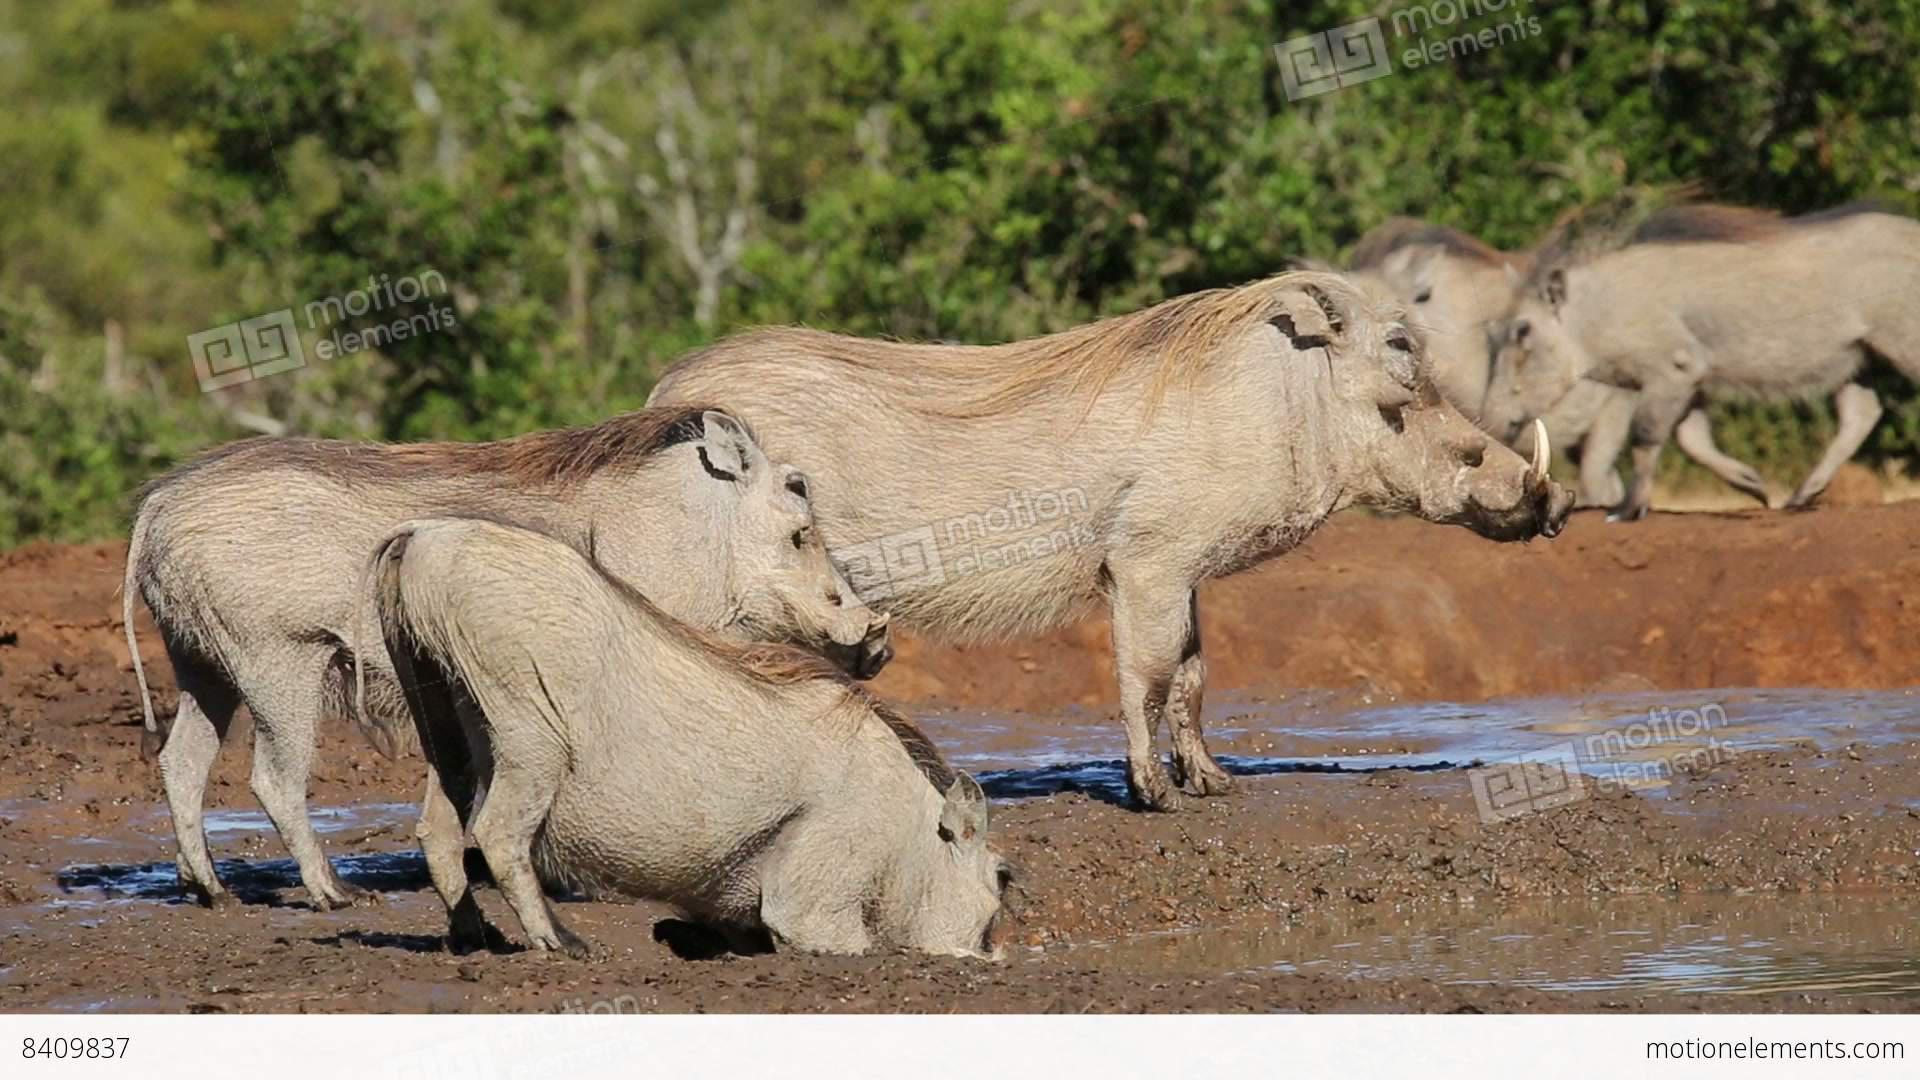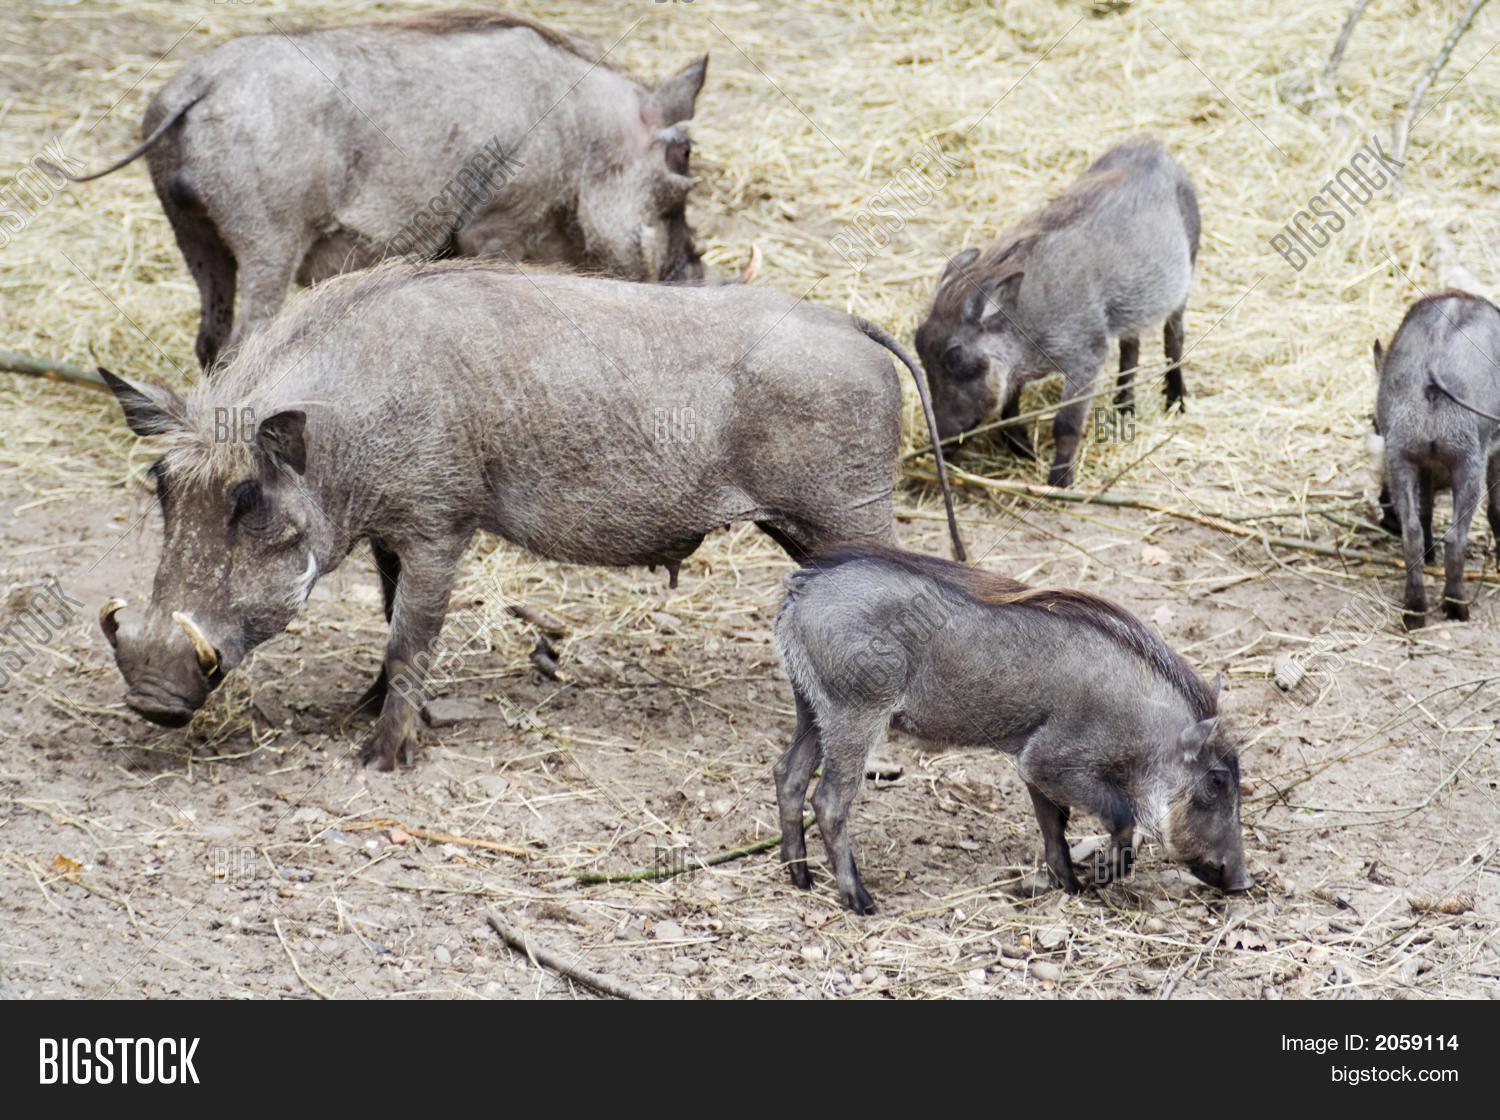The first image is the image on the left, the second image is the image on the right. Assess this claim about the two images: "There are no more than two warthogs in the image on the right.". Correct or not? Answer yes or no. No. 